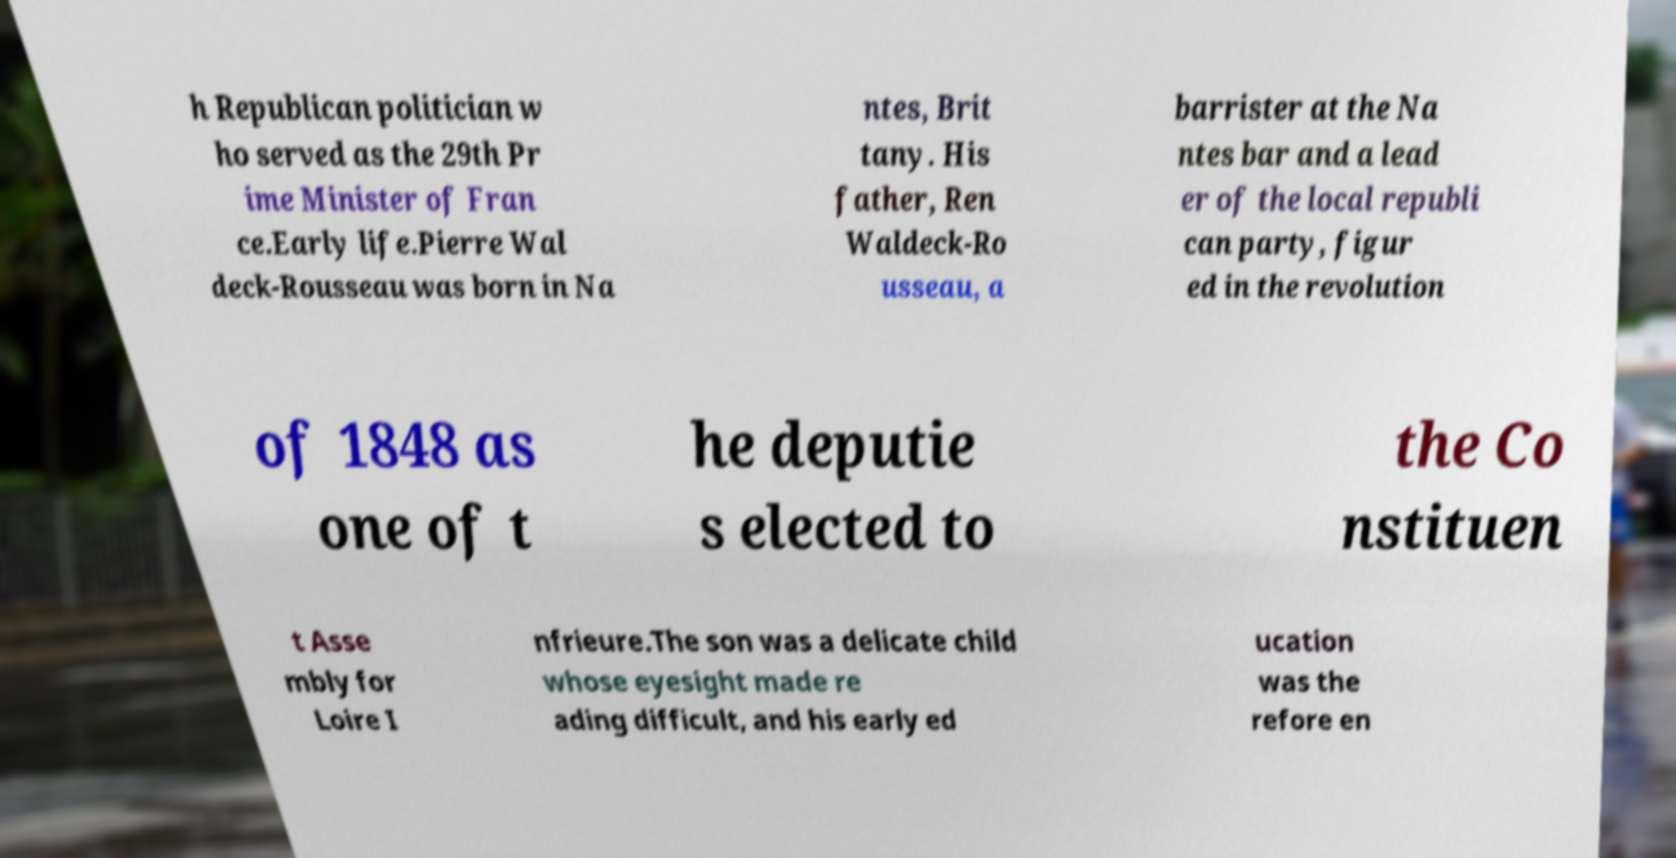Could you assist in decoding the text presented in this image and type it out clearly? h Republican politician w ho served as the 29th Pr ime Minister of Fran ce.Early life.Pierre Wal deck-Rousseau was born in Na ntes, Brit tany. His father, Ren Waldeck-Ro usseau, a barrister at the Na ntes bar and a lead er of the local republi can party, figur ed in the revolution of 1848 as one of t he deputie s elected to the Co nstituen t Asse mbly for Loire I nfrieure.The son was a delicate child whose eyesight made re ading difficult, and his early ed ucation was the refore en 